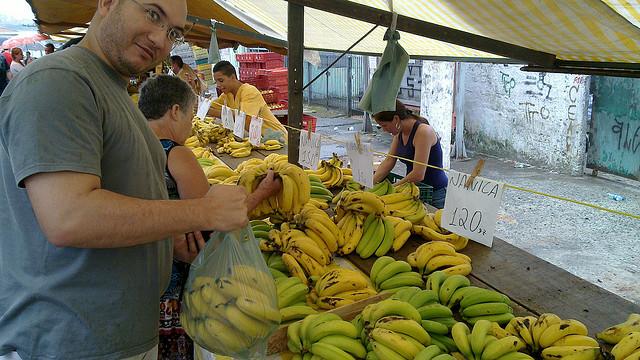How much are the bananas?
Keep it brief. 120. What are being sold?
Give a very brief answer. Bananas. Is the man buying bananas?
Quick response, please. Yes. What is the man doing with all these bananas?
Short answer required. Selling. What type of fruit is the majority in this picture?
Write a very short answer. Banana. What is this person selling?
Answer briefly. Bananas. Is this a buffet?
Keep it brief. No. Are there oranges in the picture?
Give a very brief answer. No. What is the man in green shirt try to do?
Answer briefly. Buy bananas. How many groups of bananas are hanging?
Keep it brief. 0. What is the woman wearing?
Concise answer only. Tank top. What is the man wearing?
Give a very brief answer. Shirt. Where are the bananas?
Concise answer only. Table. What are the food items for?
Keep it brief. Eating. Are these bananas ready to eat?
Give a very brief answer. Yes. What type of food items are these?
Write a very short answer. Bananas. Are all the bananas ripe?
Write a very short answer. No. How many different fruits do you see?
Concise answer only. 1. Does this man have something on his wrists?
Short answer required. No. Is there anything besides bananas for sale on the tables?
Concise answer only. No. Are this ripe bananas?
Give a very brief answer. Yes. What fruit is in the crate?
Keep it brief. Bananas. Are the bananas ready to eat?
Be succinct. Yes. Is the man wearing a jacket?
Short answer required. No. What will the people place the fruit in?
Be succinct. Bag. 